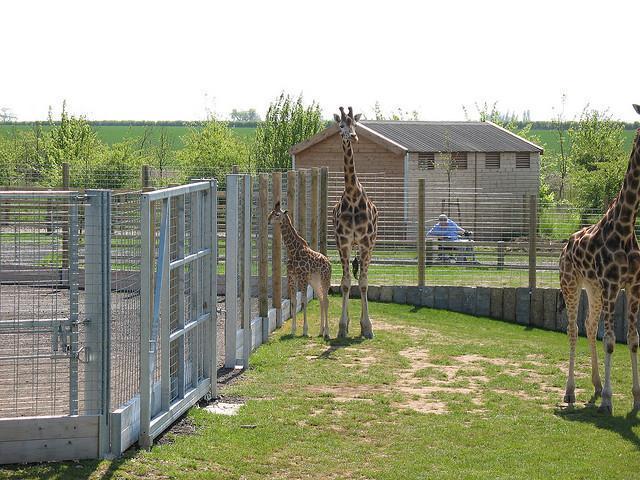How many giraffes are in the picture?
Give a very brief answer. 3. 